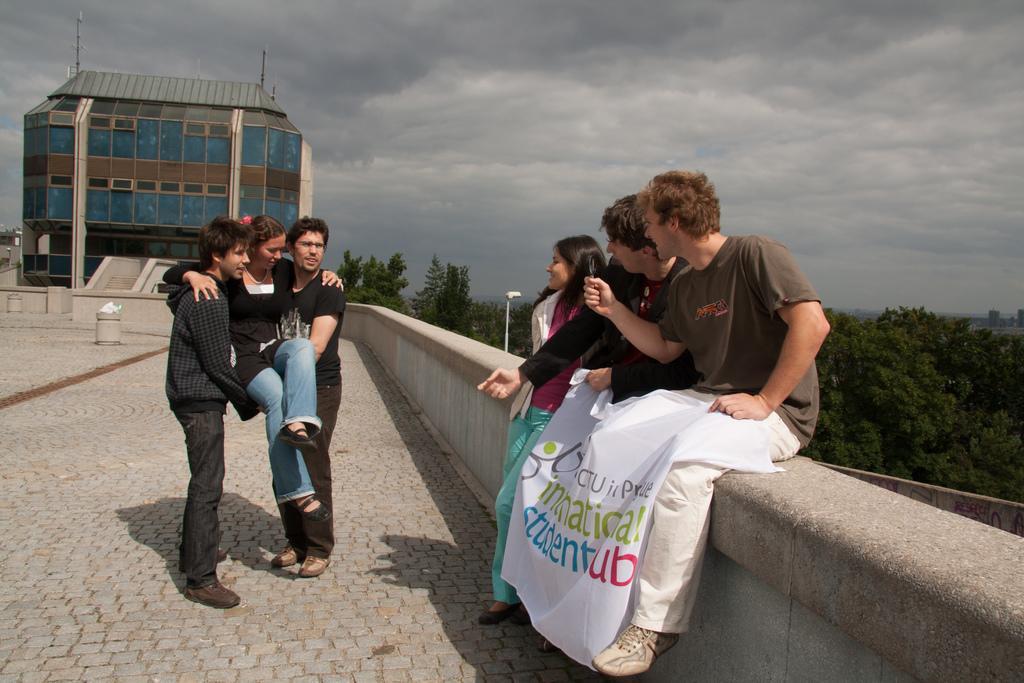In one or two sentences, can you explain what this image depicts? In this image there is the sky towards the top of the image, there are clouds in the sky, there is a building, there is a pole, there is a street light, there are trees, there are group of persons, there is a banner, there is text on the banner, there is an object on the ground. 